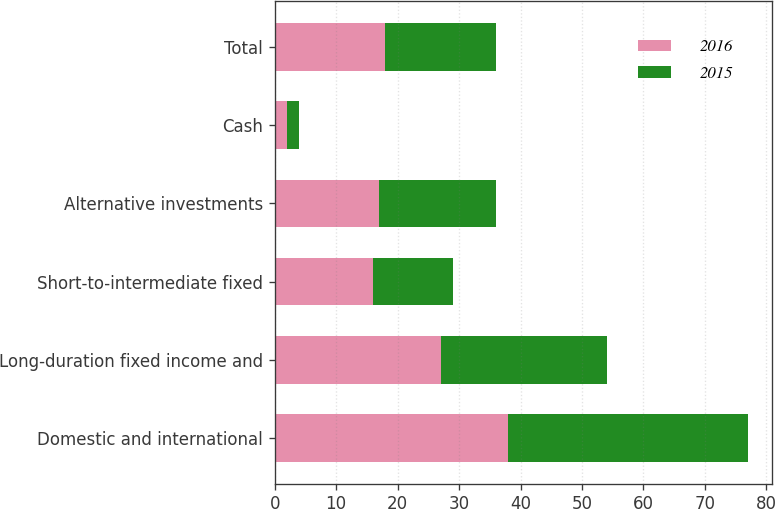Convert chart. <chart><loc_0><loc_0><loc_500><loc_500><stacked_bar_chart><ecel><fcel>Domestic and international<fcel>Long-duration fixed income and<fcel>Short-to-intermediate fixed<fcel>Alternative investments<fcel>Cash<fcel>Total<nl><fcel>2016<fcel>38<fcel>27<fcel>16<fcel>17<fcel>2<fcel>18<nl><fcel>2015<fcel>39<fcel>27<fcel>13<fcel>19<fcel>2<fcel>18<nl></chart> 